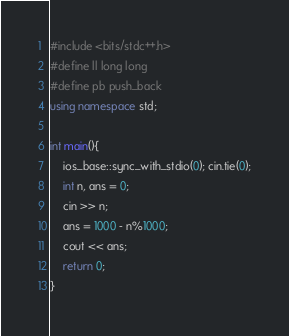<code> <loc_0><loc_0><loc_500><loc_500><_C++_>#include <bits/stdc++.h>
#define ll long long 
#define pb push_back
using namespace std;

int main(){
    ios_base::sync_with_stdio(0); cin.tie(0);
	int n, ans = 0;
	cin >> n;
	ans = 1000 - n%1000;
	cout << ans;
    return 0;
}

</code> 